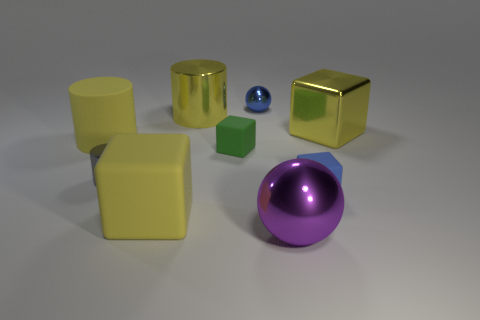Subtract all shiny cubes. How many cubes are left? 3 Subtract all green cubes. How many cubes are left? 3 Subtract all red blocks. Subtract all purple cylinders. How many blocks are left? 4 Add 1 yellow matte cylinders. How many objects exist? 10 Subtract all blocks. How many objects are left? 5 Subtract all small matte objects. Subtract all big shiny spheres. How many objects are left? 6 Add 9 big yellow shiny cylinders. How many big yellow shiny cylinders are left? 10 Add 1 big blue blocks. How many big blue blocks exist? 1 Subtract 0 brown balls. How many objects are left? 9 